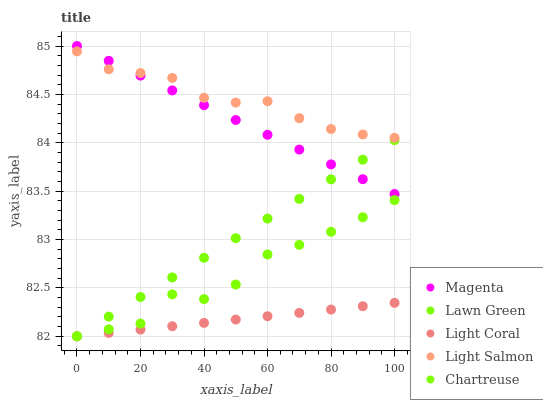Does Light Coral have the minimum area under the curve?
Answer yes or no. Yes. Does Light Salmon have the maximum area under the curve?
Answer yes or no. Yes. Does Lawn Green have the minimum area under the curve?
Answer yes or no. No. Does Lawn Green have the maximum area under the curve?
Answer yes or no. No. Is Magenta the smoothest?
Answer yes or no. Yes. Is Chartreuse the roughest?
Answer yes or no. Yes. Is Lawn Green the smoothest?
Answer yes or no. No. Is Lawn Green the roughest?
Answer yes or no. No. Does Light Coral have the lowest value?
Answer yes or no. Yes. Does Magenta have the lowest value?
Answer yes or no. No. Does Magenta have the highest value?
Answer yes or no. Yes. Does Lawn Green have the highest value?
Answer yes or no. No. Is Light Coral less than Light Salmon?
Answer yes or no. Yes. Is Magenta greater than Chartreuse?
Answer yes or no. Yes. Does Lawn Green intersect Light Coral?
Answer yes or no. Yes. Is Lawn Green less than Light Coral?
Answer yes or no. No. Is Lawn Green greater than Light Coral?
Answer yes or no. No. Does Light Coral intersect Light Salmon?
Answer yes or no. No. 